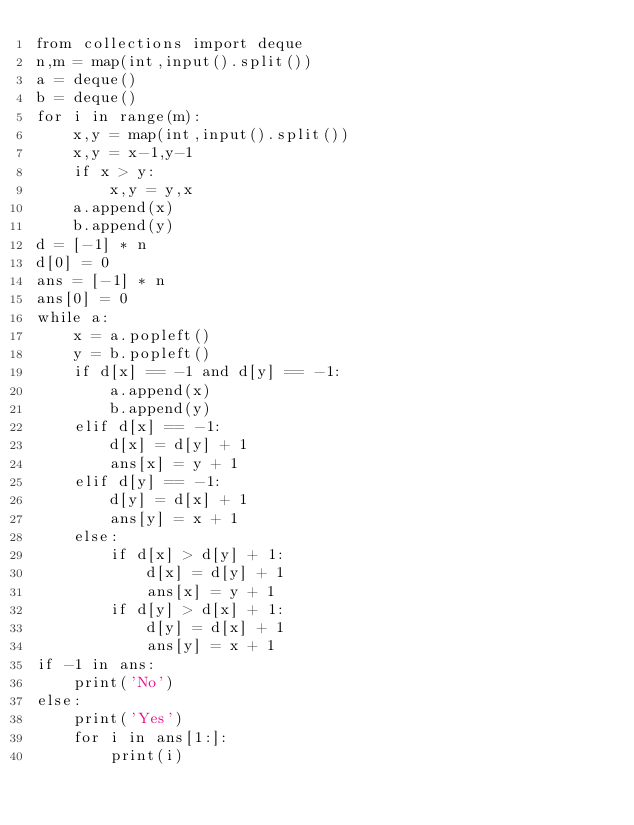Convert code to text. <code><loc_0><loc_0><loc_500><loc_500><_Cython_>from collections import deque
n,m = map(int,input().split())
a = deque()
b = deque()
for i in range(m):
    x,y = map(int,input().split())
    x,y = x-1,y-1
    if x > y:
        x,y = y,x
    a.append(x)
    b.append(y)
d = [-1] * n
d[0] = 0
ans = [-1] * n
ans[0] = 0
while a:
    x = a.popleft()
    y = b.popleft()
    if d[x] == -1 and d[y] == -1:
        a.append(x)
        b.append(y)
    elif d[x] == -1:
        d[x] = d[y] + 1
        ans[x] = y + 1
    elif d[y] == -1:
        d[y] = d[x] + 1
        ans[y] = x + 1
    else:
        if d[x] > d[y] + 1:
            d[x] = d[y] + 1
            ans[x] = y + 1
        if d[y] > d[x] + 1:
            d[y] = d[x] + 1
            ans[y] = x + 1
if -1 in ans:
    print('No')
else:
    print('Yes')
    for i in ans[1:]:
        print(i)</code> 